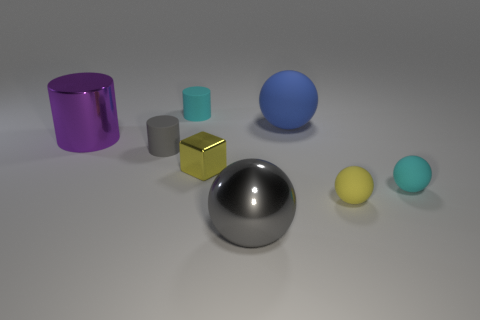What number of big metal objects are the same shape as the large rubber thing?
Make the answer very short. 1. There is a cube that is to the left of the big gray thing; is its color the same as the shiny cylinder?
Ensure brevity in your answer.  No. There is a big sphere that is behind the big thing left of the big gray ball; how many cubes are behind it?
Offer a very short reply. 0. How many matte things are right of the big blue matte thing and to the left of the tiny cyan rubber cylinder?
Offer a very short reply. 0. The other tiny object that is the same color as the small metal object is what shape?
Keep it short and to the point. Sphere. Is there anything else that has the same material as the tiny block?
Ensure brevity in your answer.  Yes. Do the large purple cylinder and the yellow sphere have the same material?
Offer a terse response. No. The small yellow thing that is in front of the small cyan matte thing to the right of the sphere that is in front of the yellow matte ball is what shape?
Offer a very short reply. Sphere. Is the number of small blocks behind the yellow metallic thing less than the number of big gray balls that are to the left of the large metallic sphere?
Offer a terse response. No. There is a gray object that is in front of the yellow thing to the right of the gray sphere; what shape is it?
Offer a very short reply. Sphere. 